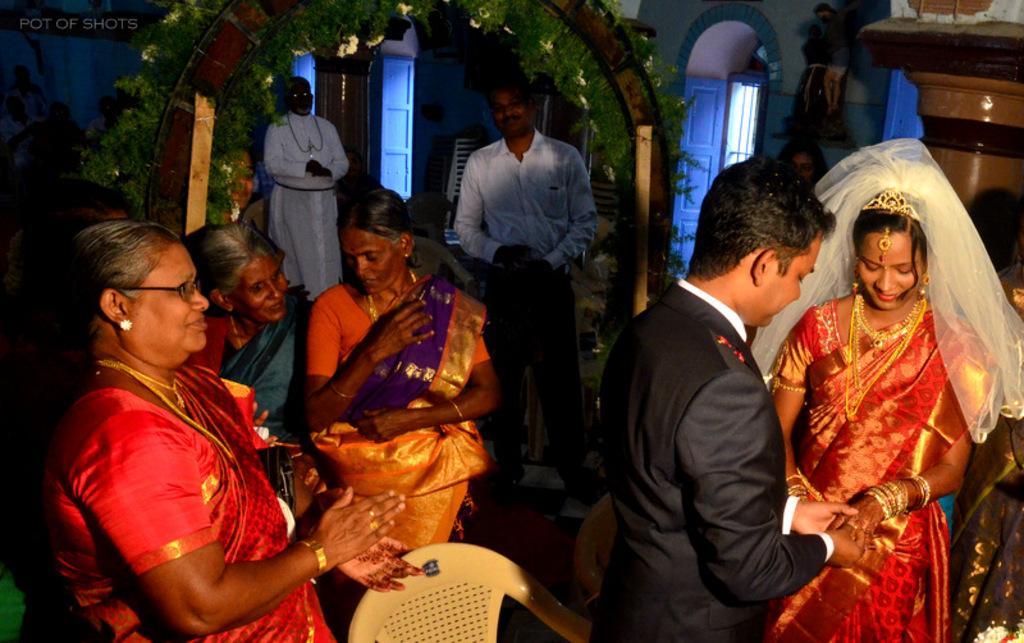Could you give a brief overview of what you see in this image? In this picture we can see a man and a woman on the right side. We can see man holding a hand of a woman. There are three women visible on the left side. We can see two people at the back. There is a pillar visible on the right side. We can see a few decorative plants on an arch. There are a few objects visible in the background. 